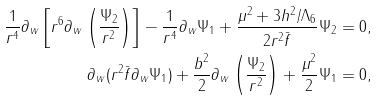<formula> <loc_0><loc_0><loc_500><loc_500>\frac { 1 } { r ^ { 4 } } \partial _ { w } \left [ r ^ { 6 } \partial _ { w } \left ( \frac { \Psi _ { 2 } } { r ^ { 2 } } \right ) \right ] - \frac { 1 } { r ^ { 4 } } \partial _ { w } \Psi _ { 1 } + \frac { \mu ^ { 2 } + 3 h ^ { 2 } / \Lambda _ { 6 } } { 2 r ^ { 2 } \bar { f } } \Psi _ { 2 } & = 0 , \\ \partial _ { w } ( r ^ { 2 } \bar { f } \partial _ { w } \Psi _ { 1 } ) + \frac { b ^ { 2 } } { 2 } \partial _ { w } \left ( \frac { \Psi _ { 2 } } { r ^ { 2 } } \right ) + \frac { \mu ^ { 2 } } { 2 } \Psi _ { 1 } & = 0 ,</formula> 